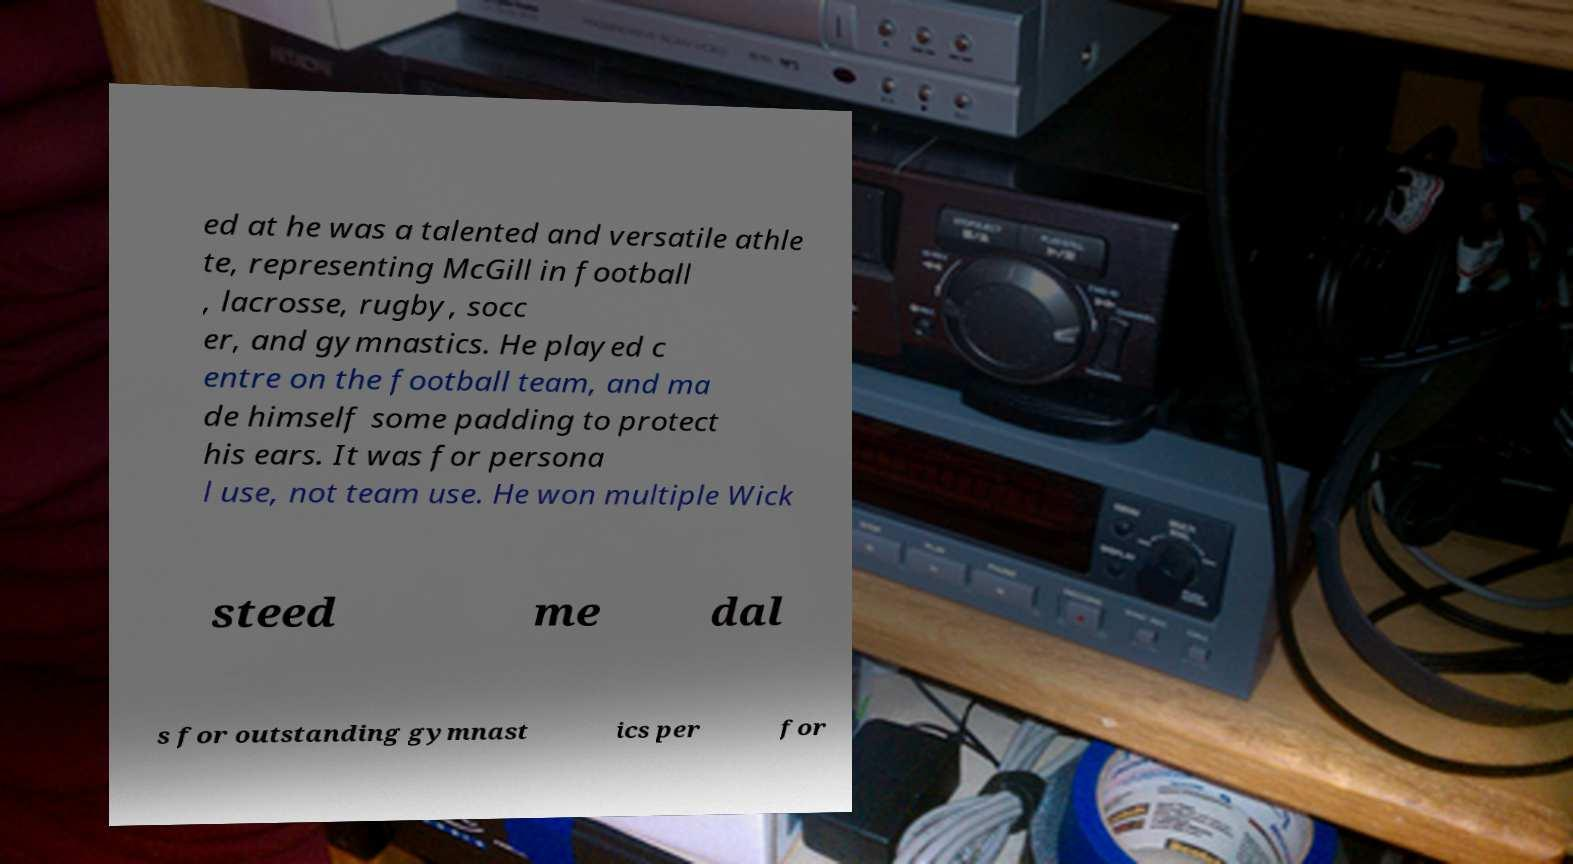Please read and relay the text visible in this image. What does it say? ed at he was a talented and versatile athle te, representing McGill in football , lacrosse, rugby, socc er, and gymnastics. He played c entre on the football team, and ma de himself some padding to protect his ears. It was for persona l use, not team use. He won multiple Wick steed me dal s for outstanding gymnast ics per for 